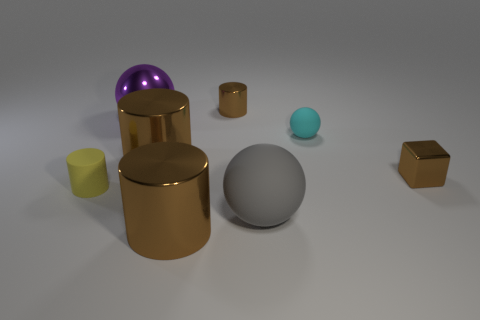How does the lighting affect the appearance of the objects? The lighting generates subtle shadows and highlights, enhancing the metallic sheen and reflective qualities of the objects, giving a sense of depth and texture. 